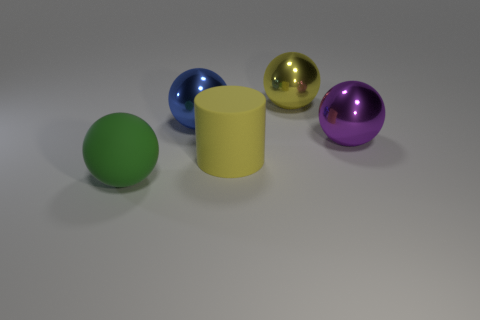What material is the big yellow object that is the same shape as the green rubber thing?
Your response must be concise. Metal. Is the number of blue metal objects behind the large green rubber thing greater than the number of big spheres?
Give a very brief answer. No. Is there anything else that has the same color as the cylinder?
Ensure brevity in your answer.  Yes. What shape is the large yellow object that is made of the same material as the big green sphere?
Your response must be concise. Cylinder. Are the large ball that is right of the big yellow metal thing and the blue sphere made of the same material?
Offer a terse response. Yes. There is a object that is the same color as the cylinder; what is its shape?
Make the answer very short. Sphere. Do the ball that is in front of the big purple sphere and the metallic object behind the large blue metallic sphere have the same color?
Offer a terse response. No. What number of metal balls are to the right of the large cylinder and on the left side of the big yellow matte thing?
Your answer should be compact. 0. What is the big yellow sphere made of?
Your answer should be compact. Metal. The purple metal thing that is the same size as the blue sphere is what shape?
Your answer should be compact. Sphere. 